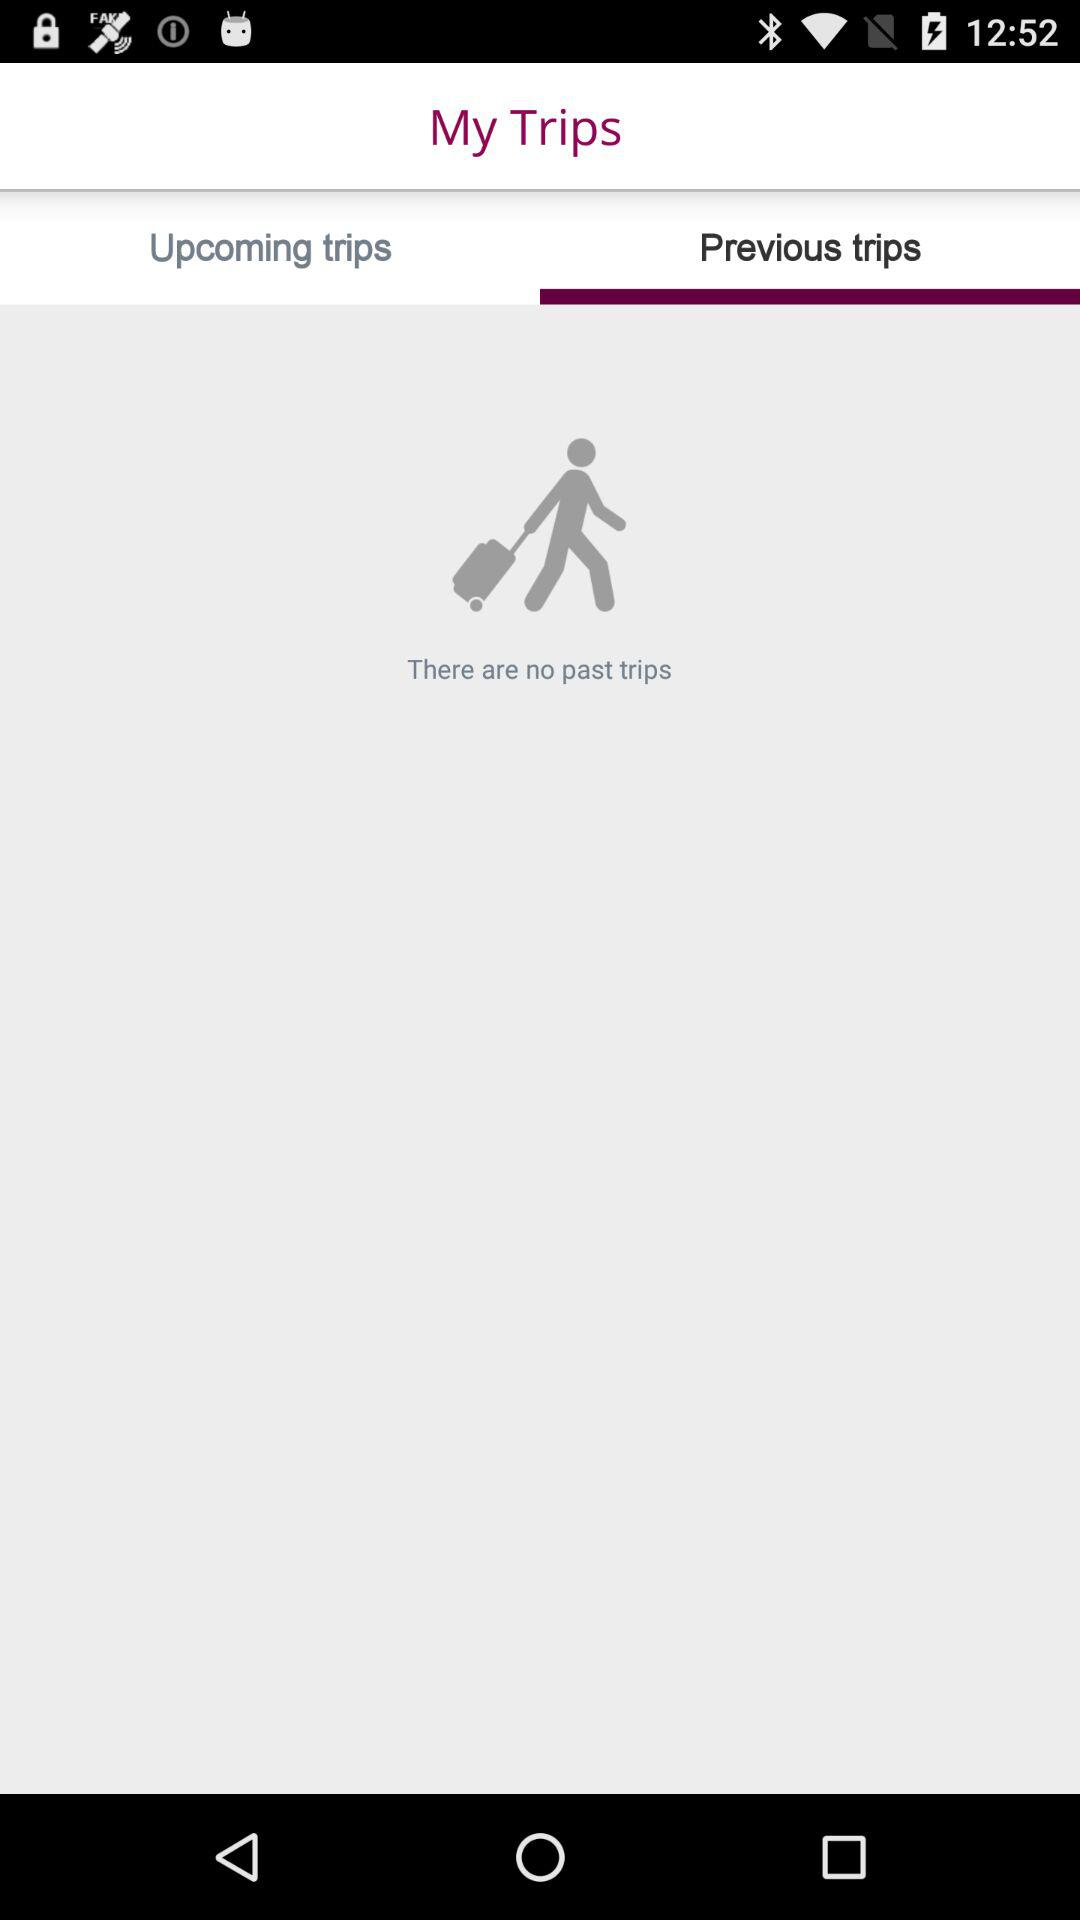Which tab is selected? The selected tab is "Previous trips". 